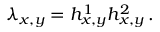Convert formula to latex. <formula><loc_0><loc_0><loc_500><loc_500>\lambda _ { x , y } = h _ { x , y } ^ { 1 } h _ { x , y } ^ { 2 } \, .</formula> 